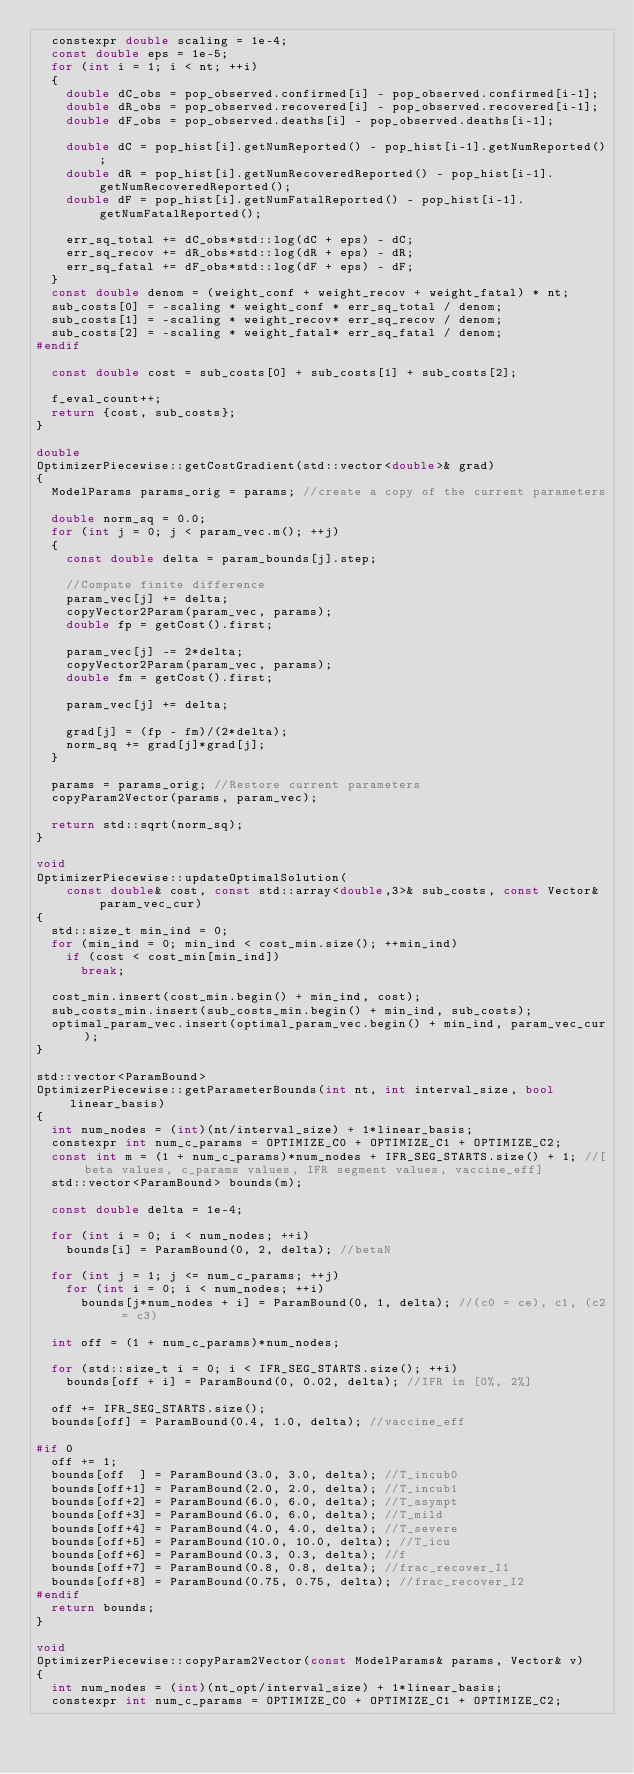<code> <loc_0><loc_0><loc_500><loc_500><_C++_>  constexpr double scaling = 1e-4;
  const double eps = 1e-5;
  for (int i = 1; i < nt; ++i)
  {
    double dC_obs = pop_observed.confirmed[i] - pop_observed.confirmed[i-1];
    double dR_obs = pop_observed.recovered[i] - pop_observed.recovered[i-1];
    double dF_obs = pop_observed.deaths[i] - pop_observed.deaths[i-1];

    double dC = pop_hist[i].getNumReported() - pop_hist[i-1].getNumReported();
    double dR = pop_hist[i].getNumRecoveredReported() - pop_hist[i-1].getNumRecoveredReported();
    double dF = pop_hist[i].getNumFatalReported() - pop_hist[i-1].getNumFatalReported();

    err_sq_total += dC_obs*std::log(dC + eps) - dC;
    err_sq_recov += dR_obs*std::log(dR + eps) - dR;
    err_sq_fatal += dF_obs*std::log(dF + eps) - dF;
  }
  const double denom = (weight_conf + weight_recov + weight_fatal) * nt;
  sub_costs[0] = -scaling * weight_conf * err_sq_total / denom;
  sub_costs[1] = -scaling * weight_recov* err_sq_recov / denom;
  sub_costs[2] = -scaling * weight_fatal* err_sq_fatal / denom;
#endif

  const double cost = sub_costs[0] + sub_costs[1] + sub_costs[2];

  f_eval_count++;
  return {cost, sub_costs};
}

double
OptimizerPiecewise::getCostGradient(std::vector<double>& grad)
{
  ModelParams params_orig = params; //create a copy of the current parameters

  double norm_sq = 0.0;
  for (int j = 0; j < param_vec.m(); ++j)
  {
    const double delta = param_bounds[j].step;

    //Compute finite difference
    param_vec[j] += delta;
    copyVector2Param(param_vec, params);
    double fp = getCost().first;

    param_vec[j] -= 2*delta;
    copyVector2Param(param_vec, params);
    double fm = getCost().first;

    param_vec[j] += delta;

    grad[j] = (fp - fm)/(2*delta);
    norm_sq += grad[j]*grad[j];
  }

  params = params_orig; //Restore current parameters
  copyParam2Vector(params, param_vec);

  return std::sqrt(norm_sq);
}

void
OptimizerPiecewise::updateOptimalSolution(
    const double& cost, const std::array<double,3>& sub_costs, const Vector& param_vec_cur)
{
  std::size_t min_ind = 0;
  for (min_ind = 0; min_ind < cost_min.size(); ++min_ind)
    if (cost < cost_min[min_ind])
      break;

  cost_min.insert(cost_min.begin() + min_ind, cost);
  sub_costs_min.insert(sub_costs_min.begin() + min_ind, sub_costs);
  optimal_param_vec.insert(optimal_param_vec.begin() + min_ind, param_vec_cur);
}

std::vector<ParamBound>
OptimizerPiecewise::getParameterBounds(int nt, int interval_size, bool linear_basis)
{
  int num_nodes = (int)(nt/interval_size) + 1*linear_basis;
  constexpr int num_c_params = OPTIMIZE_C0 + OPTIMIZE_C1 + OPTIMIZE_C2;
  const int m = (1 + num_c_params)*num_nodes + IFR_SEG_STARTS.size() + 1; //[beta values, c_params values, IFR segment values, vaccine_eff]
  std::vector<ParamBound> bounds(m);

  const double delta = 1e-4;

  for (int i = 0; i < num_nodes; ++i)
    bounds[i] = ParamBound(0, 2, delta); //betaN

  for (int j = 1; j <= num_c_params; ++j)
    for (int i = 0; i < num_nodes; ++i)
      bounds[j*num_nodes + i] = ParamBound(0, 1, delta); //(c0 = ce), c1, (c2 = c3)

  int off = (1 + num_c_params)*num_nodes;

  for (std::size_t i = 0; i < IFR_SEG_STARTS.size(); ++i)
    bounds[off + i] = ParamBound(0, 0.02, delta); //IFR in [0%, 2%]

  off += IFR_SEG_STARTS.size();
  bounds[off] = ParamBound(0.4, 1.0, delta); //vaccine_eff

#if 0
  off += 1;
  bounds[off  ] = ParamBound(3.0, 3.0, delta); //T_incub0
  bounds[off+1] = ParamBound(2.0, 2.0, delta); //T_incub1
  bounds[off+2] = ParamBound(6.0, 6.0, delta); //T_asympt
  bounds[off+3] = ParamBound(6.0, 6.0, delta); //T_mild
  bounds[off+4] = ParamBound(4.0, 4.0, delta); //T_severe
  bounds[off+5] = ParamBound(10.0, 10.0, delta); //T_icu
  bounds[off+6] = ParamBound(0.3, 0.3, delta); //f
  bounds[off+7] = ParamBound(0.8, 0.8, delta); //frac_recover_I1
  bounds[off+8] = ParamBound(0.75, 0.75, delta); //frac_recover_I2
#endif
  return bounds;
}

void
OptimizerPiecewise::copyParam2Vector(const ModelParams& params, Vector& v)
{
  int num_nodes = (int)(nt_opt/interval_size) + 1*linear_basis;
  constexpr int num_c_params = OPTIMIZE_C0 + OPTIMIZE_C1 + OPTIMIZE_C2;</code> 